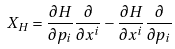Convert formula to latex. <formula><loc_0><loc_0><loc_500><loc_500>X _ { H } = \frac { \partial H } { \partial p _ { i } } \frac { \partial } { \partial x ^ { i } } - \frac { \partial H } { \partial x ^ { i } } \frac { \partial } { \partial p _ { i } }</formula> 